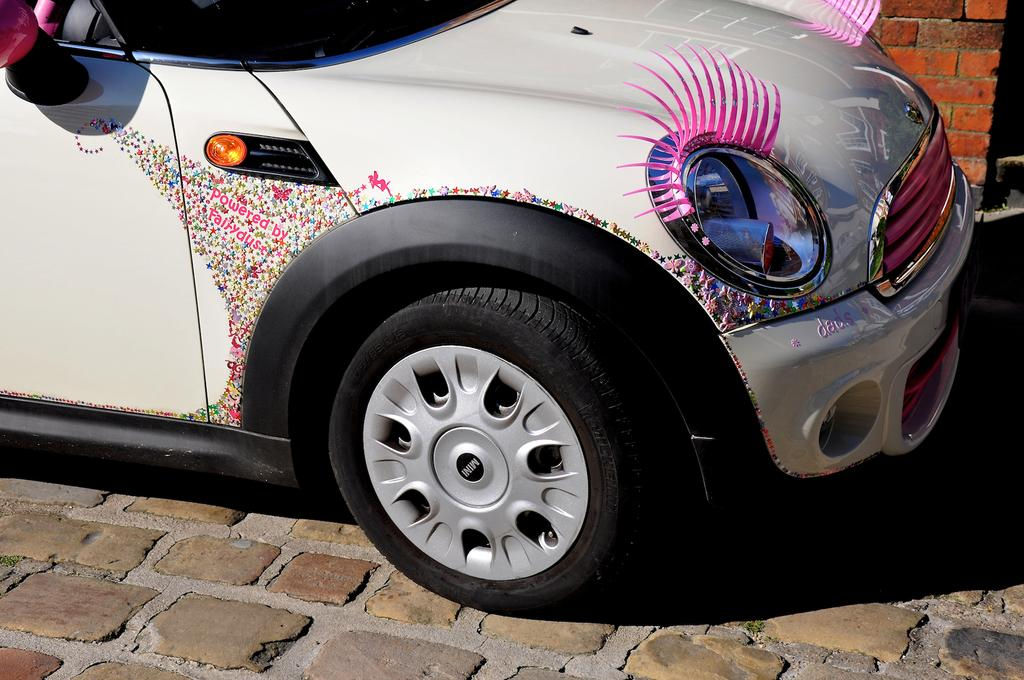What is the main subject of the image? There is a vehicle in the image. What is the vehicle resting on? The vehicle is on a surface. What else can be seen in the image besides the vehicle? There is a wall in the image. What grade does the vehicle receive for its performance in the image? There is no indication of the vehicle's performance or any grading system in the image. What year is the vehicle from in the image? The image does not provide any information about the vehicle's year of manufacture. 